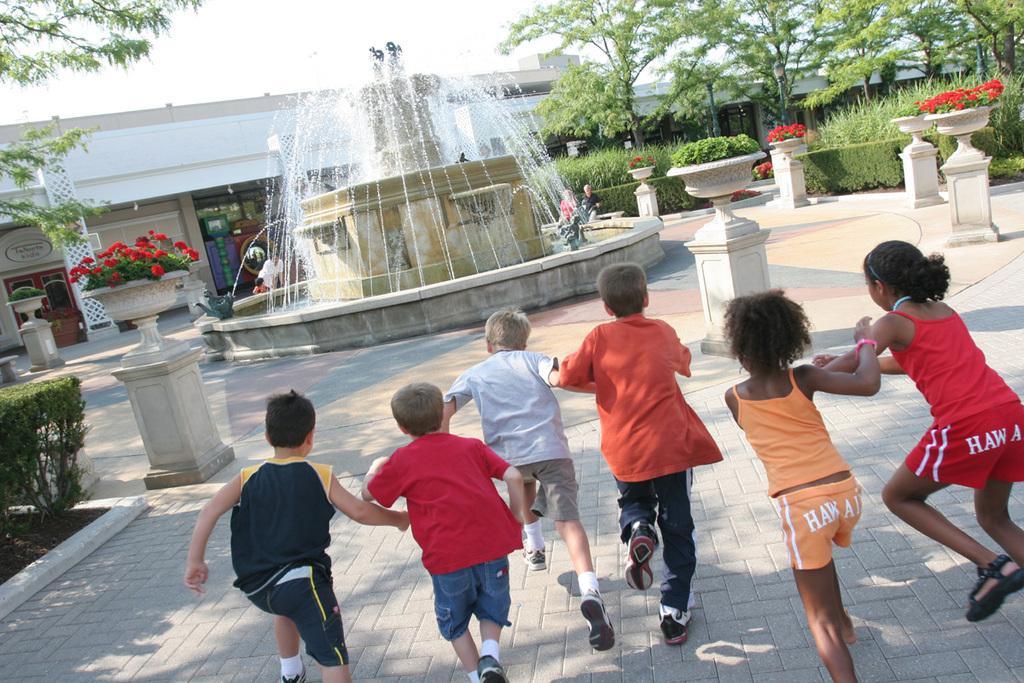Please provide a concise description of this image. In the image there are group of kids running towards a water fountain,many plants are kept around the fountain. There is a complex behind the fountain and in the right side there are few trees. 